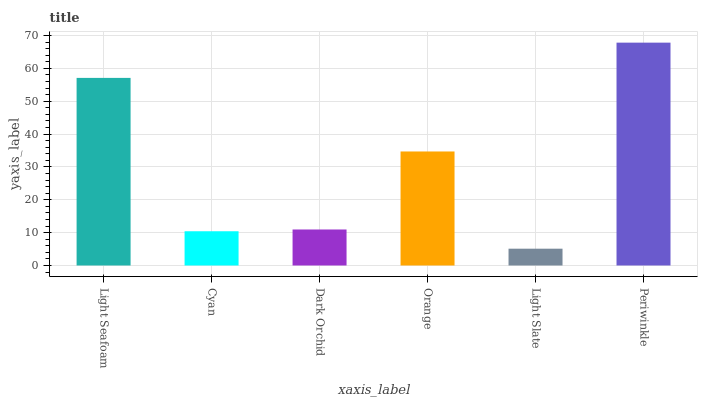Is Cyan the minimum?
Answer yes or no. No. Is Cyan the maximum?
Answer yes or no. No. Is Light Seafoam greater than Cyan?
Answer yes or no. Yes. Is Cyan less than Light Seafoam?
Answer yes or no. Yes. Is Cyan greater than Light Seafoam?
Answer yes or no. No. Is Light Seafoam less than Cyan?
Answer yes or no. No. Is Orange the high median?
Answer yes or no. Yes. Is Dark Orchid the low median?
Answer yes or no. Yes. Is Dark Orchid the high median?
Answer yes or no. No. Is Orange the low median?
Answer yes or no. No. 